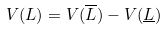Convert formula to latex. <formula><loc_0><loc_0><loc_500><loc_500>V ( L ) = V ( \overline { L } ) - V ( \underline { L } )</formula> 